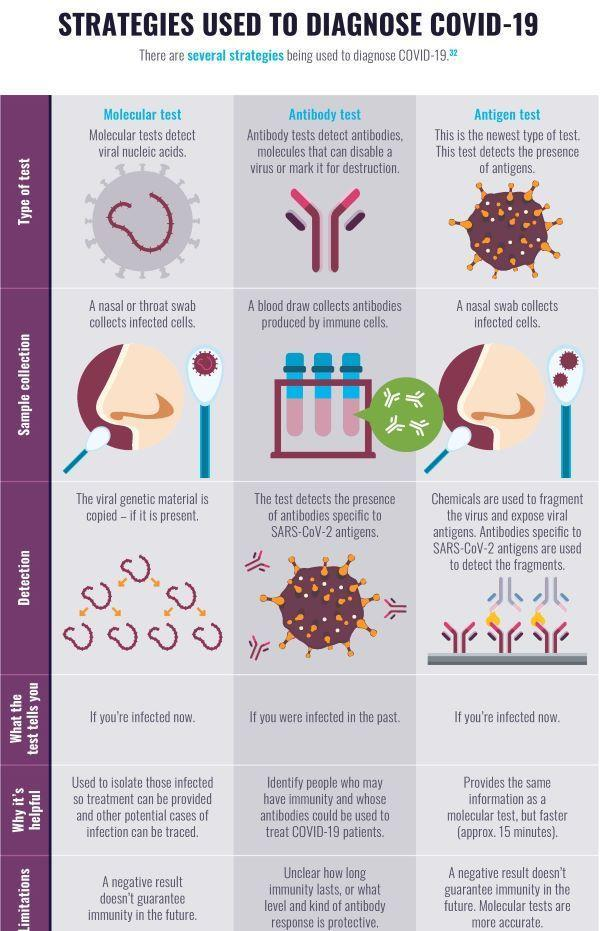How many corona test types are listed in the infographic?
Answer the question with a short phrase. 3 Which test helps to determine persons who have successfully recovered from corona without any problematic issues? Antibody test Which is the corona test that gives more precise result? Antigen test For which corona test only the nasal swab can be taken? Antigen test Which are the corona tests to be done to check a person is currently corona positive or not? Molecular test, Antigen test Which corona test is the current best? Antigen test For which corona tests nasal or throat swab is taken? Molecular test, Antigen test Which corona tests confirms the person tested had infected with corona sometime earlier? Antibody test 